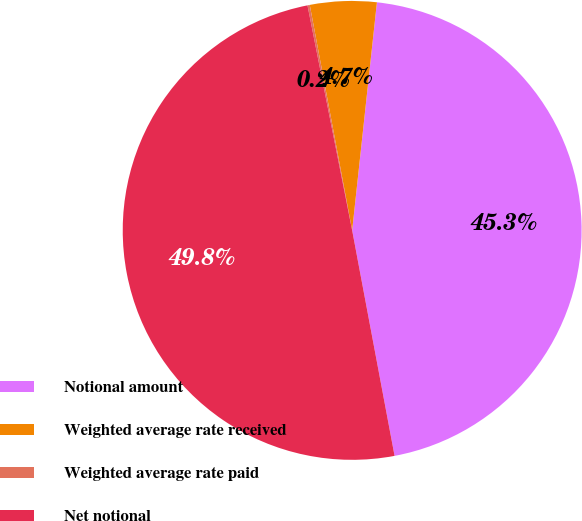Convert chart. <chart><loc_0><loc_0><loc_500><loc_500><pie_chart><fcel>Notional amount<fcel>Weighted average rate received<fcel>Weighted average rate paid<fcel>Net notional<nl><fcel>45.32%<fcel>4.68%<fcel>0.16%<fcel>49.84%<nl></chart> 